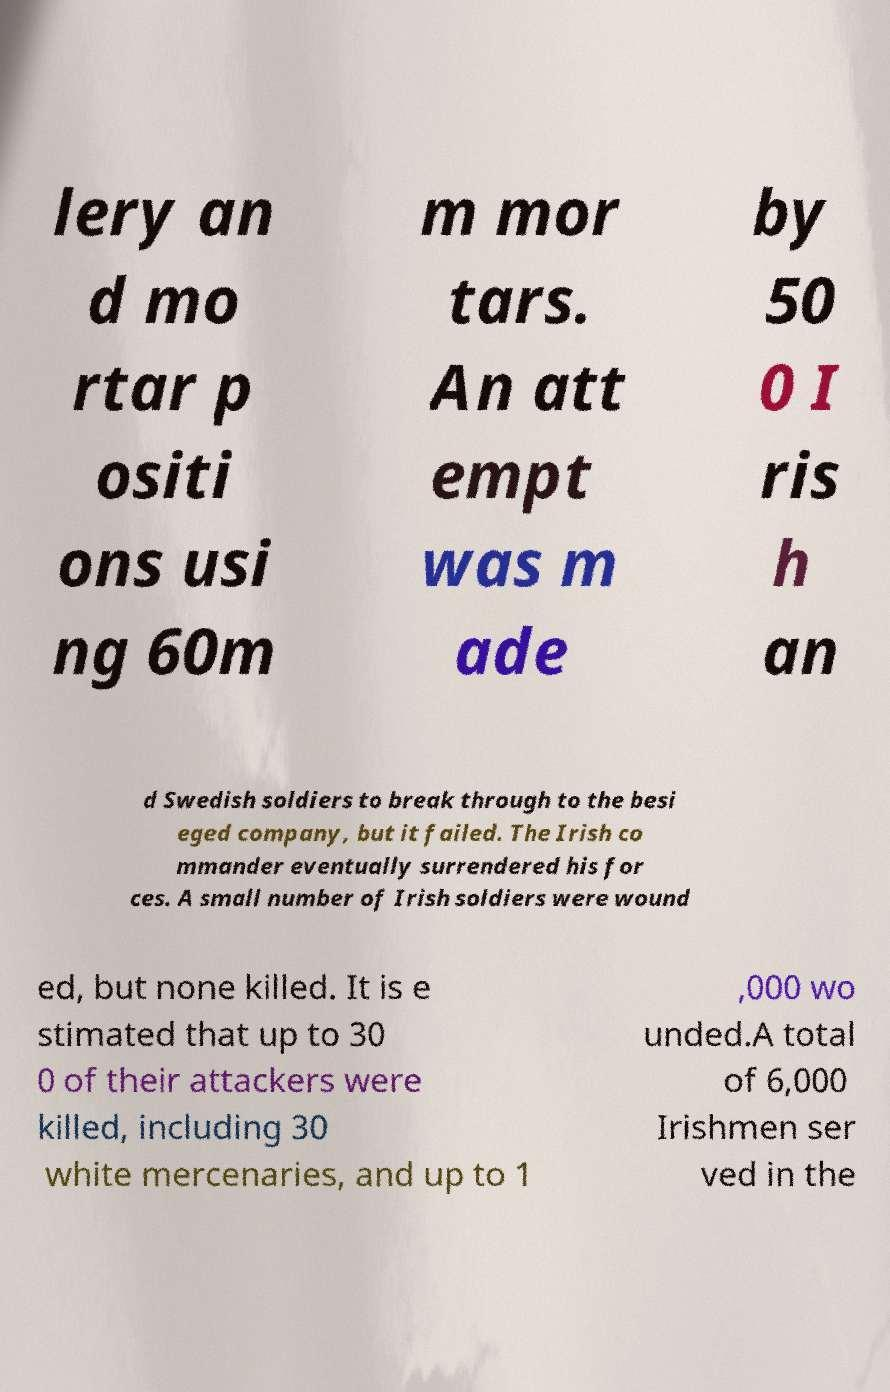What messages or text are displayed in this image? I need them in a readable, typed format. lery an d mo rtar p ositi ons usi ng 60m m mor tars. An att empt was m ade by 50 0 I ris h an d Swedish soldiers to break through to the besi eged company, but it failed. The Irish co mmander eventually surrendered his for ces. A small number of Irish soldiers were wound ed, but none killed. It is e stimated that up to 30 0 of their attackers were killed, including 30 white mercenaries, and up to 1 ,000 wo unded.A total of 6,000 Irishmen ser ved in the 